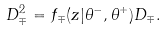Convert formula to latex. <formula><loc_0><loc_0><loc_500><loc_500>D _ { \mp } ^ { 2 } = f _ { \mp } ( z | \theta ^ { - } , \theta ^ { + } ) D _ { \mp } .</formula> 